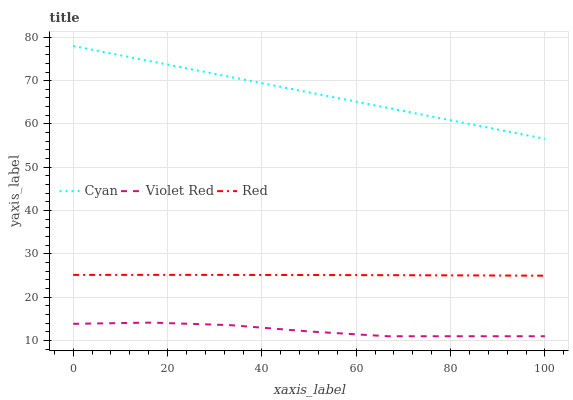Does Violet Red have the minimum area under the curve?
Answer yes or no. Yes. Does Cyan have the maximum area under the curve?
Answer yes or no. Yes. Does Red have the minimum area under the curve?
Answer yes or no. No. Does Red have the maximum area under the curve?
Answer yes or no. No. Is Cyan the smoothest?
Answer yes or no. Yes. Is Violet Red the roughest?
Answer yes or no. Yes. Is Red the smoothest?
Answer yes or no. No. Is Red the roughest?
Answer yes or no. No. Does Red have the lowest value?
Answer yes or no. No. Does Red have the highest value?
Answer yes or no. No. Is Violet Red less than Red?
Answer yes or no. Yes. Is Cyan greater than Red?
Answer yes or no. Yes. Does Violet Red intersect Red?
Answer yes or no. No. 